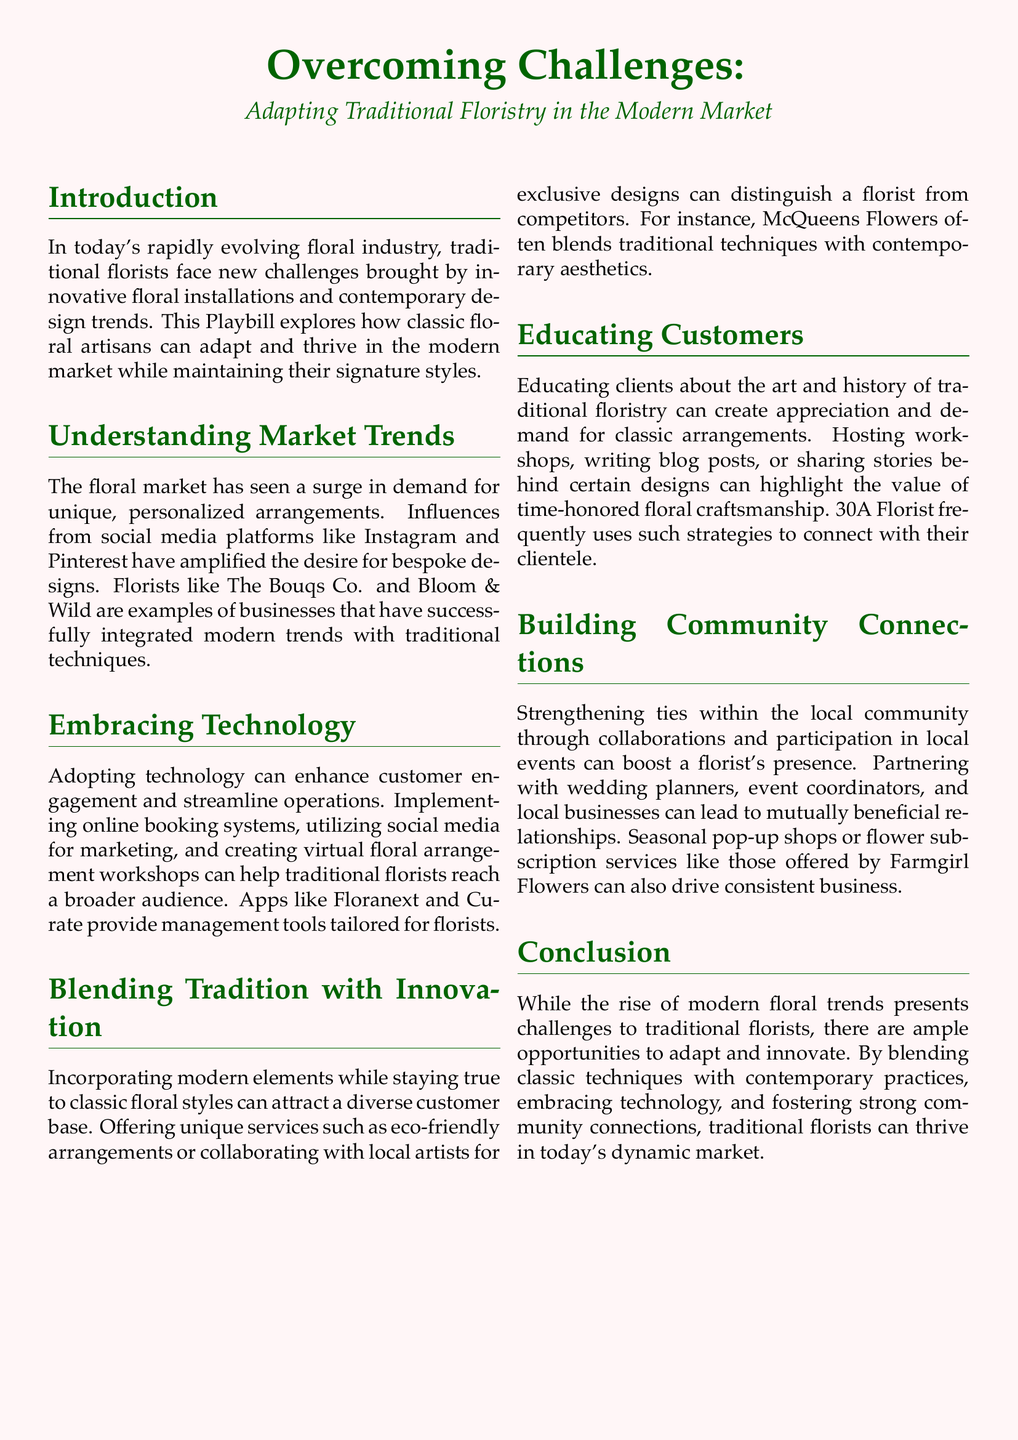What is the primary theme of the Playbill? The primary theme of the Playbill focuses on adapting traditional floristry to meet modern market demands and challenges.
Answer: Adapting traditional floristry Which two companies are highlighted as examples of successful integration of modern trends? The document mentions florists that have successfully integrated modern trends with traditional techniques.
Answer: The Bouqs Co. and Bloom & Wild What is one potential benefit of embracing technology for traditional florists? The document details advantages of adopting technology, such as enhancing customer engagement.
Answer: Customer engagement What unique service could distinguish a florist from competitors according to the document? The document suggests offering unique services like eco-friendly arrangements or collaborations with local artists.
Answer: Eco-friendly arrangements How can traditional florists educate their customers? The Playbill offers methods traditional florists can use to educate clients, such as hosting workshops and writing blog posts.
Answer: Hosting workshops What type of community connections can boost a florist's presence? The document discusses the importance of strengthening ties by partnering with local businesses and event coordinators.
Answer: Collaborations Which floristry example is mentioned for blending traditional and contemporary techniques? The document references a florist that blends classic and modern aesthetics effectively.
Answer: McQueens Flowers How can seasonal pop-up shops benefit a florist? The document implies that seasonal pop-up shops can drive consistent business.
Answer: Drive consistent business What is a recommended strategy to create appreciation for classic arrangements? The Playbill highlights strategies that can increase appreciation for traditional floristry, like sharing historical insights.
Answer: Sharing stories What is the color scheme of the document? The document uses a specific color scheme for visual appeal, notably a pink background with green text.
Answer: Pink and green 